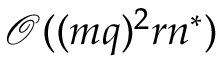Convert formula to latex. <formula><loc_0><loc_0><loc_500><loc_500>\mathcal { O } ( ( m q ) ^ { 2 } r n ^ { * } )</formula> 